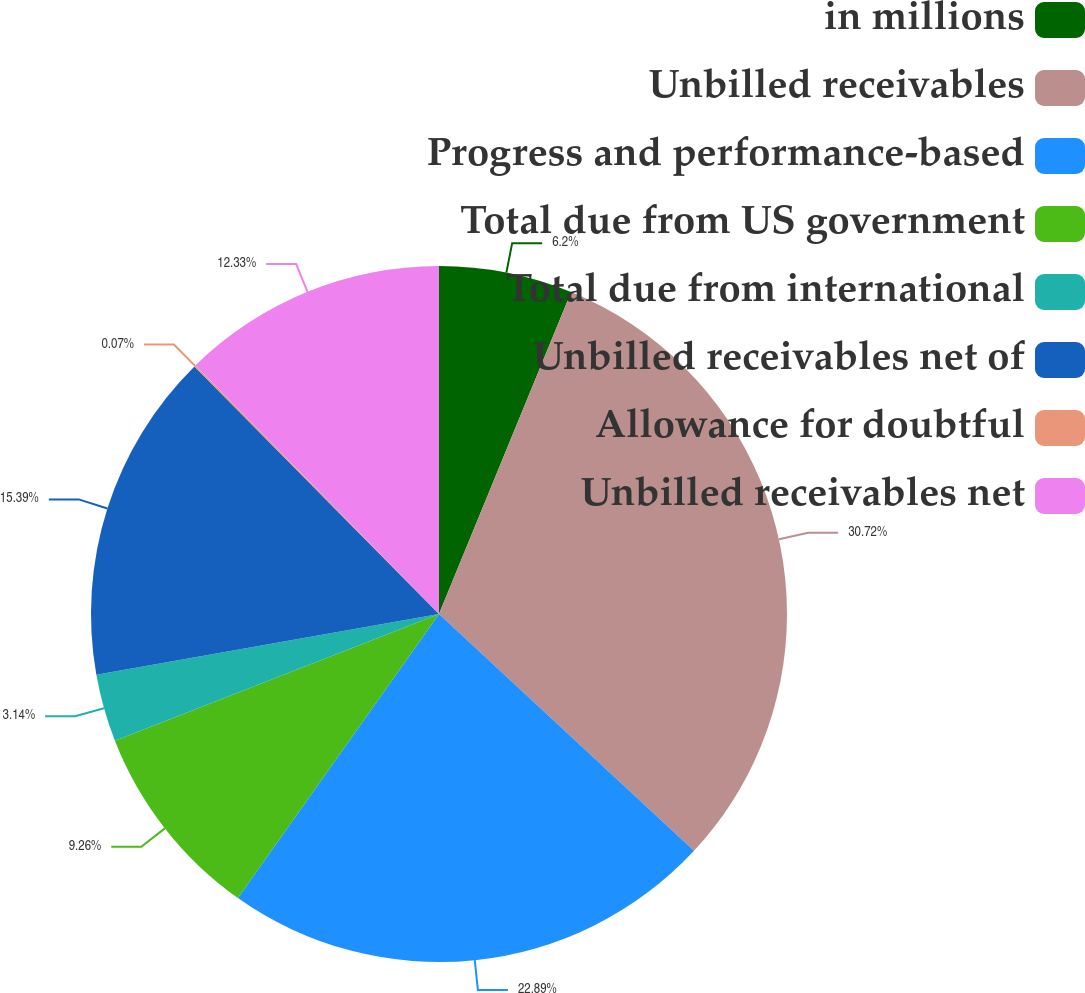Convert chart to OTSL. <chart><loc_0><loc_0><loc_500><loc_500><pie_chart><fcel>in millions<fcel>Unbilled receivables<fcel>Progress and performance-based<fcel>Total due from US government<fcel>Total due from international<fcel>Unbilled receivables net of<fcel>Allowance for doubtful<fcel>Unbilled receivables net<nl><fcel>6.2%<fcel>30.71%<fcel>22.89%<fcel>9.26%<fcel>3.14%<fcel>15.39%<fcel>0.07%<fcel>12.33%<nl></chart> 